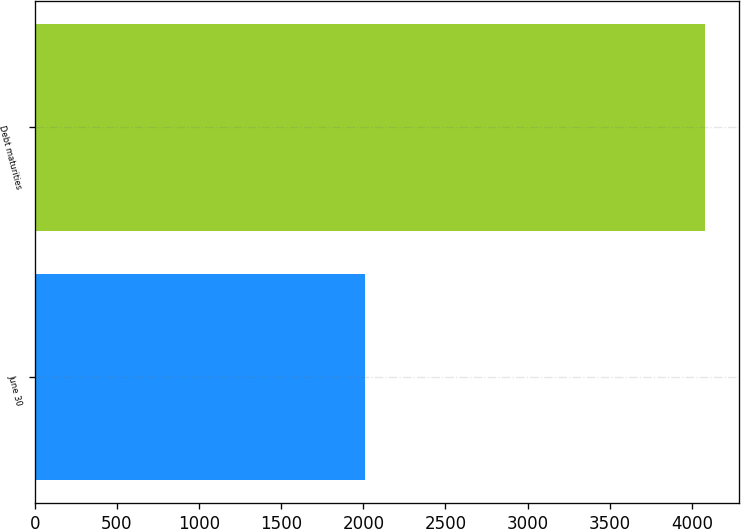Convert chart. <chart><loc_0><loc_0><loc_500><loc_500><bar_chart><fcel>June 30<fcel>Debt maturities<nl><fcel>2013<fcel>4083<nl></chart> 